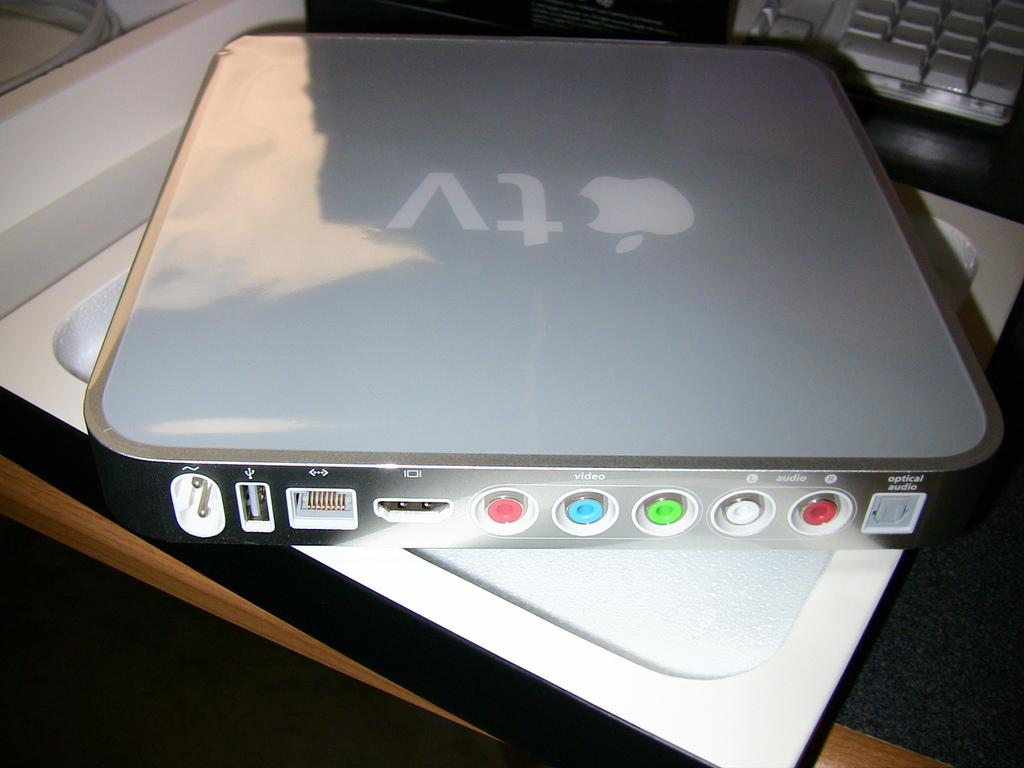<image>
Share a concise interpretation of the image provided. An older version of an AppleTV in the box. 